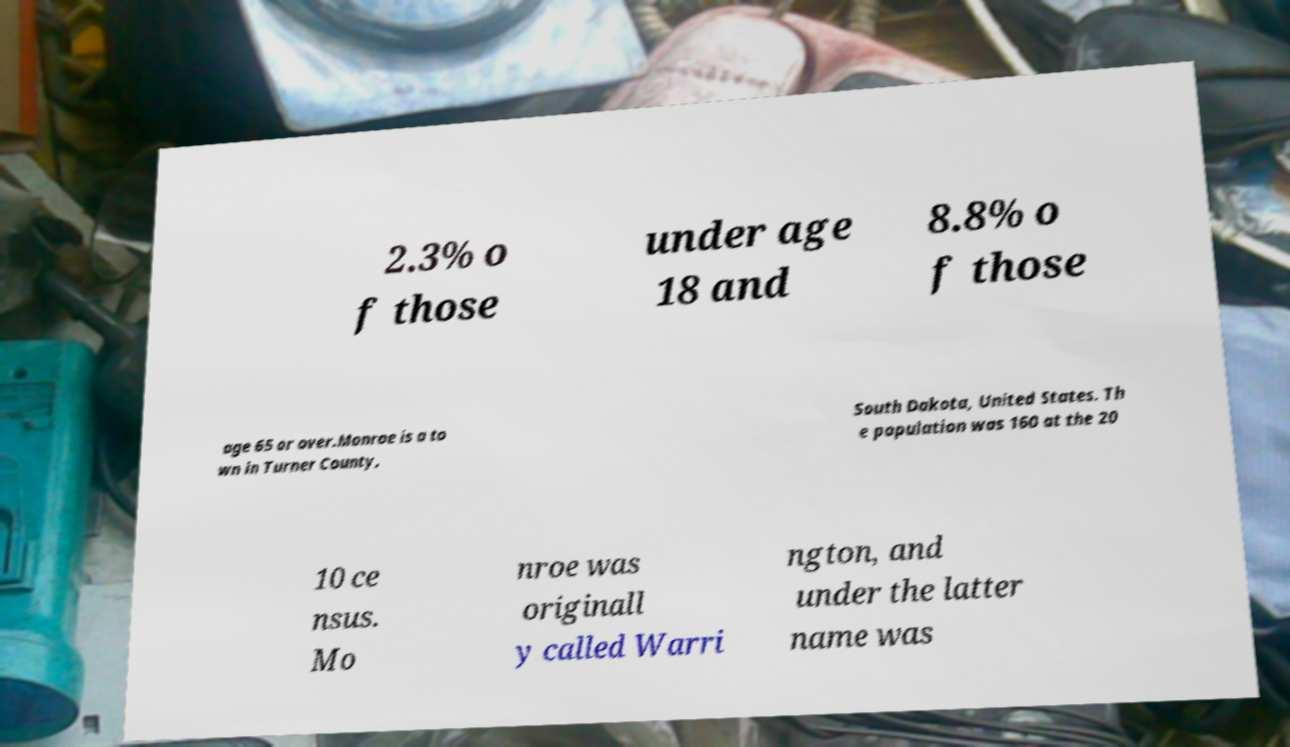For documentation purposes, I need the text within this image transcribed. Could you provide that? 2.3% o f those under age 18 and 8.8% o f those age 65 or over.Monroe is a to wn in Turner County, South Dakota, United States. Th e population was 160 at the 20 10 ce nsus. Mo nroe was originall y called Warri ngton, and under the latter name was 